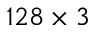Convert formula to latex. <formula><loc_0><loc_0><loc_500><loc_500>1 2 8 \times 3</formula> 